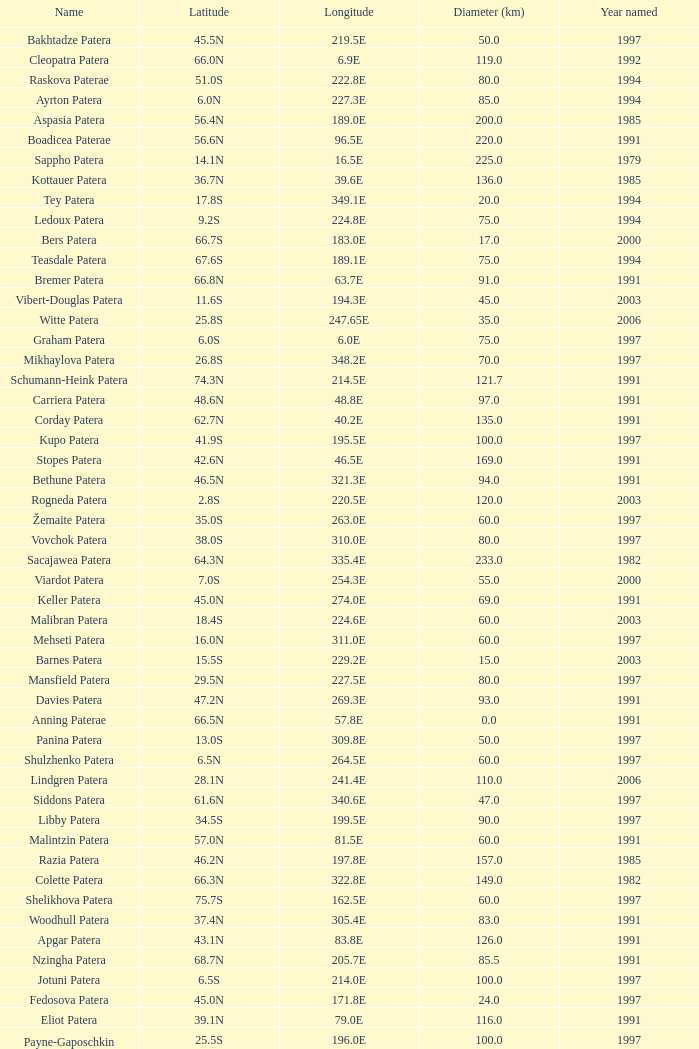What is Year Named, when Longitude is 227.5E? 1997.0. 